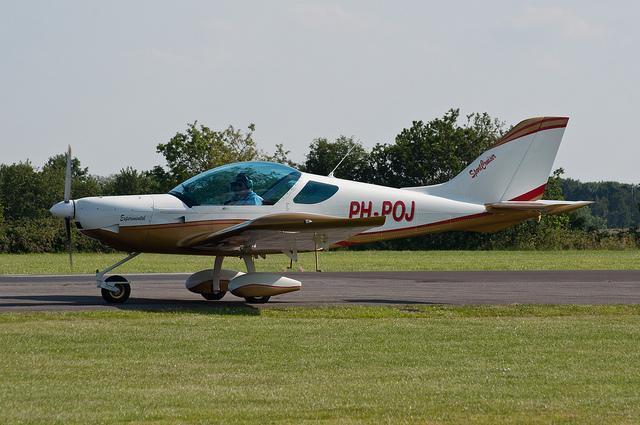How many wheels are visible?
Give a very brief answer. 3. 